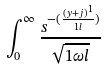<formula> <loc_0><loc_0><loc_500><loc_500>\int _ { 0 } ^ { \infty } \frac { s ^ { - ( \frac { ( y + j ) ^ { 1 } } { 1 l } ) } } { \sqrt { 1 \omega l } }</formula> 